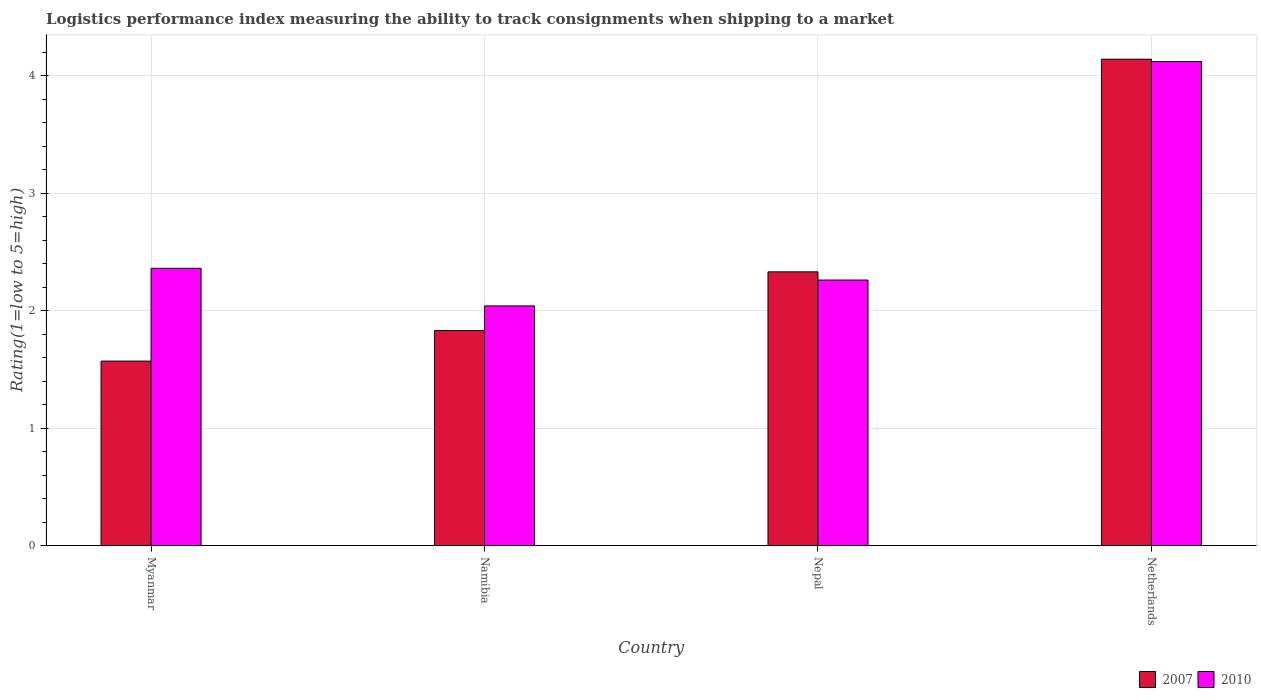How many different coloured bars are there?
Your answer should be very brief. 2. Are the number of bars per tick equal to the number of legend labels?
Keep it short and to the point. Yes. How many bars are there on the 2nd tick from the left?
Your answer should be compact. 2. What is the label of the 3rd group of bars from the left?
Keep it short and to the point. Nepal. What is the Logistic performance index in 2010 in Myanmar?
Offer a very short reply. 2.36. Across all countries, what is the maximum Logistic performance index in 2010?
Keep it short and to the point. 4.12. Across all countries, what is the minimum Logistic performance index in 2010?
Provide a short and direct response. 2.04. In which country was the Logistic performance index in 2007 minimum?
Offer a terse response. Myanmar. What is the total Logistic performance index in 2010 in the graph?
Make the answer very short. 10.78. What is the difference between the Logistic performance index in 2007 in Namibia and that in Netherlands?
Your response must be concise. -2.31. What is the difference between the Logistic performance index in 2007 in Netherlands and the Logistic performance index in 2010 in Namibia?
Offer a very short reply. 2.1. What is the average Logistic performance index in 2007 per country?
Offer a very short reply. 2.47. What is the difference between the Logistic performance index of/in 2010 and Logistic performance index of/in 2007 in Namibia?
Offer a terse response. 0.21. What is the ratio of the Logistic performance index in 2007 in Myanmar to that in Netherlands?
Your answer should be very brief. 0.38. What is the difference between the highest and the lowest Logistic performance index in 2007?
Your answer should be very brief. 2.57. What does the 1st bar from the left in Myanmar represents?
Ensure brevity in your answer.  2007. What does the 1st bar from the right in Netherlands represents?
Your answer should be compact. 2010. Are all the bars in the graph horizontal?
Make the answer very short. No. What is the difference between two consecutive major ticks on the Y-axis?
Offer a very short reply. 1. Are the values on the major ticks of Y-axis written in scientific E-notation?
Your answer should be compact. No. Where does the legend appear in the graph?
Provide a short and direct response. Bottom right. What is the title of the graph?
Your response must be concise. Logistics performance index measuring the ability to track consignments when shipping to a market. What is the label or title of the X-axis?
Provide a short and direct response. Country. What is the label or title of the Y-axis?
Provide a succinct answer. Rating(1=low to 5=high). What is the Rating(1=low to 5=high) in 2007 in Myanmar?
Your response must be concise. 1.57. What is the Rating(1=low to 5=high) of 2010 in Myanmar?
Make the answer very short. 2.36. What is the Rating(1=low to 5=high) of 2007 in Namibia?
Your response must be concise. 1.83. What is the Rating(1=low to 5=high) in 2010 in Namibia?
Provide a succinct answer. 2.04. What is the Rating(1=low to 5=high) of 2007 in Nepal?
Make the answer very short. 2.33. What is the Rating(1=low to 5=high) in 2010 in Nepal?
Your answer should be very brief. 2.26. What is the Rating(1=low to 5=high) in 2007 in Netherlands?
Give a very brief answer. 4.14. What is the Rating(1=low to 5=high) of 2010 in Netherlands?
Your answer should be very brief. 4.12. Across all countries, what is the maximum Rating(1=low to 5=high) of 2007?
Provide a succinct answer. 4.14. Across all countries, what is the maximum Rating(1=low to 5=high) in 2010?
Provide a succinct answer. 4.12. Across all countries, what is the minimum Rating(1=low to 5=high) of 2007?
Give a very brief answer. 1.57. Across all countries, what is the minimum Rating(1=low to 5=high) in 2010?
Give a very brief answer. 2.04. What is the total Rating(1=low to 5=high) in 2007 in the graph?
Your answer should be compact. 9.87. What is the total Rating(1=low to 5=high) in 2010 in the graph?
Keep it short and to the point. 10.78. What is the difference between the Rating(1=low to 5=high) in 2007 in Myanmar and that in Namibia?
Your answer should be compact. -0.26. What is the difference between the Rating(1=low to 5=high) in 2010 in Myanmar and that in Namibia?
Make the answer very short. 0.32. What is the difference between the Rating(1=low to 5=high) in 2007 in Myanmar and that in Nepal?
Give a very brief answer. -0.76. What is the difference between the Rating(1=low to 5=high) of 2010 in Myanmar and that in Nepal?
Give a very brief answer. 0.1. What is the difference between the Rating(1=low to 5=high) of 2007 in Myanmar and that in Netherlands?
Provide a short and direct response. -2.57. What is the difference between the Rating(1=low to 5=high) in 2010 in Myanmar and that in Netherlands?
Provide a succinct answer. -1.76. What is the difference between the Rating(1=low to 5=high) of 2010 in Namibia and that in Nepal?
Offer a terse response. -0.22. What is the difference between the Rating(1=low to 5=high) of 2007 in Namibia and that in Netherlands?
Offer a very short reply. -2.31. What is the difference between the Rating(1=low to 5=high) in 2010 in Namibia and that in Netherlands?
Your answer should be very brief. -2.08. What is the difference between the Rating(1=low to 5=high) of 2007 in Nepal and that in Netherlands?
Your response must be concise. -1.81. What is the difference between the Rating(1=low to 5=high) of 2010 in Nepal and that in Netherlands?
Provide a succinct answer. -1.86. What is the difference between the Rating(1=low to 5=high) of 2007 in Myanmar and the Rating(1=low to 5=high) of 2010 in Namibia?
Keep it short and to the point. -0.47. What is the difference between the Rating(1=low to 5=high) of 2007 in Myanmar and the Rating(1=low to 5=high) of 2010 in Nepal?
Give a very brief answer. -0.69. What is the difference between the Rating(1=low to 5=high) of 2007 in Myanmar and the Rating(1=low to 5=high) of 2010 in Netherlands?
Your answer should be very brief. -2.55. What is the difference between the Rating(1=low to 5=high) of 2007 in Namibia and the Rating(1=low to 5=high) of 2010 in Nepal?
Your answer should be very brief. -0.43. What is the difference between the Rating(1=low to 5=high) in 2007 in Namibia and the Rating(1=low to 5=high) in 2010 in Netherlands?
Provide a succinct answer. -2.29. What is the difference between the Rating(1=low to 5=high) of 2007 in Nepal and the Rating(1=low to 5=high) of 2010 in Netherlands?
Give a very brief answer. -1.79. What is the average Rating(1=low to 5=high) in 2007 per country?
Make the answer very short. 2.47. What is the average Rating(1=low to 5=high) in 2010 per country?
Ensure brevity in your answer.  2.69. What is the difference between the Rating(1=low to 5=high) in 2007 and Rating(1=low to 5=high) in 2010 in Myanmar?
Your answer should be very brief. -0.79. What is the difference between the Rating(1=low to 5=high) in 2007 and Rating(1=low to 5=high) in 2010 in Namibia?
Offer a terse response. -0.21. What is the difference between the Rating(1=low to 5=high) in 2007 and Rating(1=low to 5=high) in 2010 in Nepal?
Offer a very short reply. 0.07. What is the ratio of the Rating(1=low to 5=high) of 2007 in Myanmar to that in Namibia?
Ensure brevity in your answer.  0.86. What is the ratio of the Rating(1=low to 5=high) of 2010 in Myanmar to that in Namibia?
Your answer should be compact. 1.16. What is the ratio of the Rating(1=low to 5=high) of 2007 in Myanmar to that in Nepal?
Give a very brief answer. 0.67. What is the ratio of the Rating(1=low to 5=high) in 2010 in Myanmar to that in Nepal?
Offer a very short reply. 1.04. What is the ratio of the Rating(1=low to 5=high) of 2007 in Myanmar to that in Netherlands?
Give a very brief answer. 0.38. What is the ratio of the Rating(1=low to 5=high) in 2010 in Myanmar to that in Netherlands?
Offer a very short reply. 0.57. What is the ratio of the Rating(1=low to 5=high) in 2007 in Namibia to that in Nepal?
Give a very brief answer. 0.79. What is the ratio of the Rating(1=low to 5=high) in 2010 in Namibia to that in Nepal?
Keep it short and to the point. 0.9. What is the ratio of the Rating(1=low to 5=high) in 2007 in Namibia to that in Netherlands?
Ensure brevity in your answer.  0.44. What is the ratio of the Rating(1=low to 5=high) in 2010 in Namibia to that in Netherlands?
Your answer should be very brief. 0.5. What is the ratio of the Rating(1=low to 5=high) in 2007 in Nepal to that in Netherlands?
Offer a terse response. 0.56. What is the ratio of the Rating(1=low to 5=high) of 2010 in Nepal to that in Netherlands?
Make the answer very short. 0.55. What is the difference between the highest and the second highest Rating(1=low to 5=high) of 2007?
Provide a short and direct response. 1.81. What is the difference between the highest and the second highest Rating(1=low to 5=high) of 2010?
Your answer should be compact. 1.76. What is the difference between the highest and the lowest Rating(1=low to 5=high) in 2007?
Offer a terse response. 2.57. What is the difference between the highest and the lowest Rating(1=low to 5=high) of 2010?
Your answer should be very brief. 2.08. 